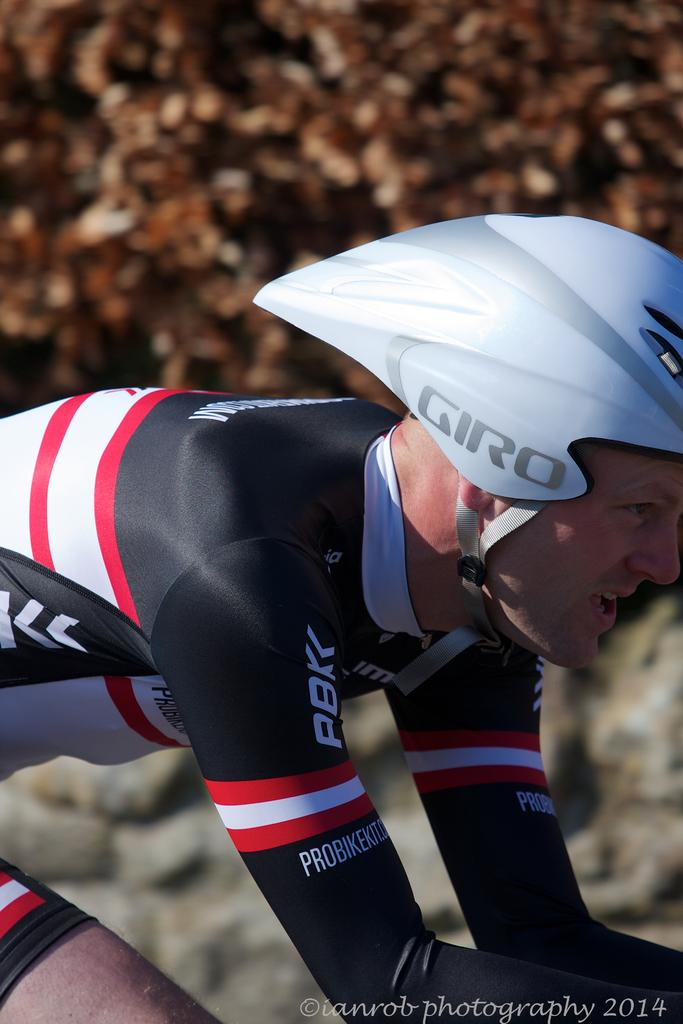Who is present in the image? There is a man in the image. What is the man wearing on his head? The man is wearing a helmet. Can you describe the background of the image? The background of the image is blurry. What can be found at the right bottom of the image? There is some text at the right bottom of the image. What type of liquid is being poured by the actor in the image? There is no actor or liquid present in the image; it features a man wearing a helmet with a blurry background and text at the right bottom. 